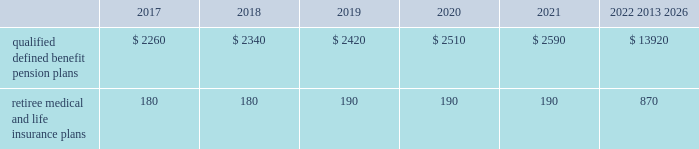Contributions and expected benefit payments the funding of our qualified defined benefit pension plans is determined in accordance with erisa , as amended by the ppa , and in a manner consistent with cas and internal revenue code rules .
There were no contributions to our legacy qualified defined benefit pension plans during 2016 .
We do not plan to make contributions to our legacy pension plans in 2017 because none are required using current assumptions including investment returns on plan assets .
We made $ 23 million in contributions during 2016 to our newly established sikorsky pension plan and expect to make $ 45 million in contributions to this plan during 2017 .
The table presents estimated future benefit payments , which reflect expected future employee service , as of december 31 , 2016 ( in millions ) : .
Defined contribution plans we maintain a number of defined contribution plans , most with 401 ( k ) features , that cover substantially all of our employees .
Under the provisions of our 401 ( k ) plans , we match most employees 2019 eligible contributions at rates specified in the plan documents .
Our contributions were $ 617 million in 2016 , $ 393 million in 2015 and $ 385 million in 2014 , the majority of which were funded in our common stock .
Our defined contribution plans held approximately 36.9 million and 40.0 million shares of our common stock as of december 31 , 2016 and 2015 .
Note 12 2013 stockholders 2019 equity at december 31 , 2016 and 2015 , our authorized capital was composed of 1.5 billion shares of common stock and 50 million shares of series preferred stock .
Of the 290 million shares of common stock issued and outstanding as of december 31 , 2016 , 289 million shares were considered outstanding for consolidated balance sheet presentation purposes ; the remaining shares were held in a separate trust .
Of the 305 million shares of common stock issued and outstanding as of december 31 , 2015 , 303 million shares were considered outstanding for consolidated balance sheet presentation purposes ; the remaining shares were held in a separate trust .
No shares of preferred stock were issued and outstanding at december 31 , 2016 or 2015 .
Repurchases of common stock during 2016 , we repurchased 8.9 million shares of our common stock for $ 2.1 billion .
During 2015 and 2014 , we paid $ 3.1 billion and $ 1.9 billion to repurchase 15.2 million and 11.5 million shares of our common stock .
On september 22 , 2016 , our board of directors approved a $ 2.0 billion increase to our share repurchase program .
Inclusive of this increase , the total remaining authorization for future common share repurchases under our program was $ 3.5 billion as of december 31 , 2016 .
As we repurchase our common shares , we reduce common stock for the $ 1 of par value of the shares repurchased , with the excess purchase price over par value recorded as a reduction of additional paid-in capital .
Due to the volume of repurchases made under our share repurchase program , additional paid-in capital was reduced to zero , with the remainder of the excess purchase price over par value of $ 1.7 billion and $ 2.4 billion recorded as a reduction of retained earnings in 2016 and 2015 .
We paid dividends totaling $ 2.0 billion ( $ 6.77 per share ) in 2016 , $ 1.9 billion ( $ 6.15 per share ) in 2015 and $ 1.8 billion ( $ 5.49 per share ) in 2014 .
We have increased our quarterly dividend rate in each of the last three years , including a 10% ( 10 % ) increase in the quarterly dividend rate in the fourth quarter of 2016 .
We declared quarterly dividends of $ 1.65 per share during each of the first three quarters of 2016 and $ 1.82 per share during the fourth quarter of 2016 ; $ 1.50 per share during each of the first three quarters of 2015 and $ 1.65 per share during the fourth quarter of 2015 ; and $ 1.33 per share during each of the first three quarters of 2014 and $ 1.50 per share during the fourth quarter of 2014. .
What is the average price of repurchased shares during 2015? 
Computations: ((3.1 / 1000) / 15.2)
Answer: 0.0002. 